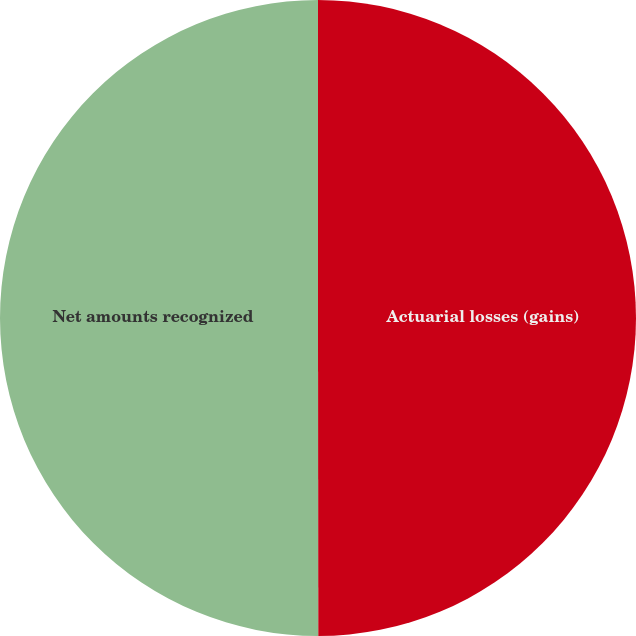Convert chart. <chart><loc_0><loc_0><loc_500><loc_500><pie_chart><fcel>Actuarial losses (gains)<fcel>Net amounts recognized<nl><fcel>49.99%<fcel>50.01%<nl></chart> 